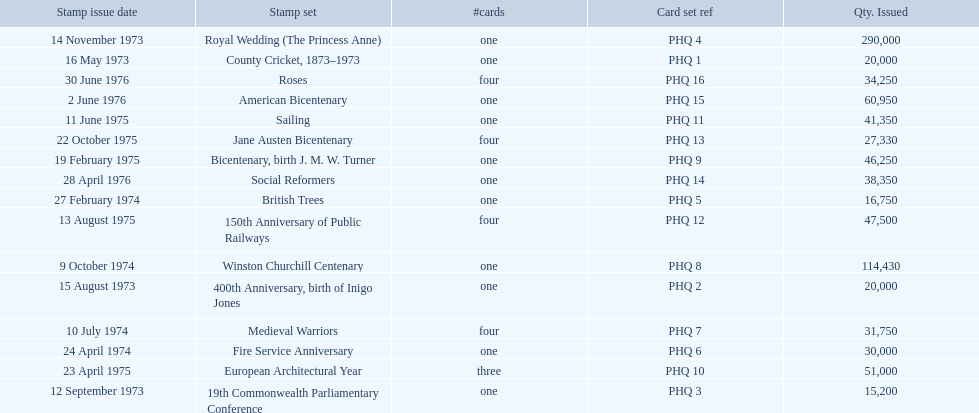Which stamp sets were issued? County Cricket, 1873–1973, 400th Anniversary, birth of Inigo Jones, 19th Commonwealth Parliamentary Conference, Royal Wedding (The Princess Anne), British Trees, Fire Service Anniversary, Medieval Warriors, Winston Churchill Centenary, Bicentenary, birth J. M. W. Turner, European Architectural Year, Sailing, 150th Anniversary of Public Railways, Jane Austen Bicentenary, Social Reformers, American Bicentenary, Roses. Of those stamp sets, which had more that 200,000 issued? Royal Wedding (The Princess Anne). Give me the full table as a dictionary. {'header': ['Stamp issue date', 'Stamp set', '#cards', 'Card set ref', 'Qty. Issued'], 'rows': [['14 November 1973', 'Royal Wedding (The Princess Anne)', 'one', 'PHQ 4', '290,000'], ['16 May 1973', 'County Cricket, 1873–1973', 'one', 'PHQ 1', '20,000'], ['30 June 1976', 'Roses', 'four', 'PHQ 16', '34,250'], ['2 June 1976', 'American Bicentenary', 'one', 'PHQ 15', '60,950'], ['11 June 1975', 'Sailing', 'one', 'PHQ 11', '41,350'], ['22 October 1975', 'Jane Austen Bicentenary', 'four', 'PHQ 13', '27,330'], ['19 February 1975', 'Bicentenary, birth J. M. W. Turner', 'one', 'PHQ 9', '46,250'], ['28 April 1976', 'Social Reformers', 'one', 'PHQ 14', '38,350'], ['27 February 1974', 'British Trees', 'one', 'PHQ 5', '16,750'], ['13 August 1975', '150th Anniversary of Public Railways', 'four', 'PHQ 12', '47,500'], ['9 October 1974', 'Winston Churchill Centenary', 'one', 'PHQ 8', '114,430'], ['15 August 1973', '400th Anniversary, birth of Inigo Jones', 'one', 'PHQ 2', '20,000'], ['10 July 1974', 'Medieval Warriors', 'four', 'PHQ 7', '31,750'], ['24 April 1974', 'Fire Service Anniversary', 'one', 'PHQ 6', '30,000'], ['23 April 1975', 'European Architectural Year', 'three', 'PHQ 10', '51,000'], ['12 September 1973', '19th Commonwealth Parliamentary Conference', 'one', 'PHQ 3', '15,200']]} 